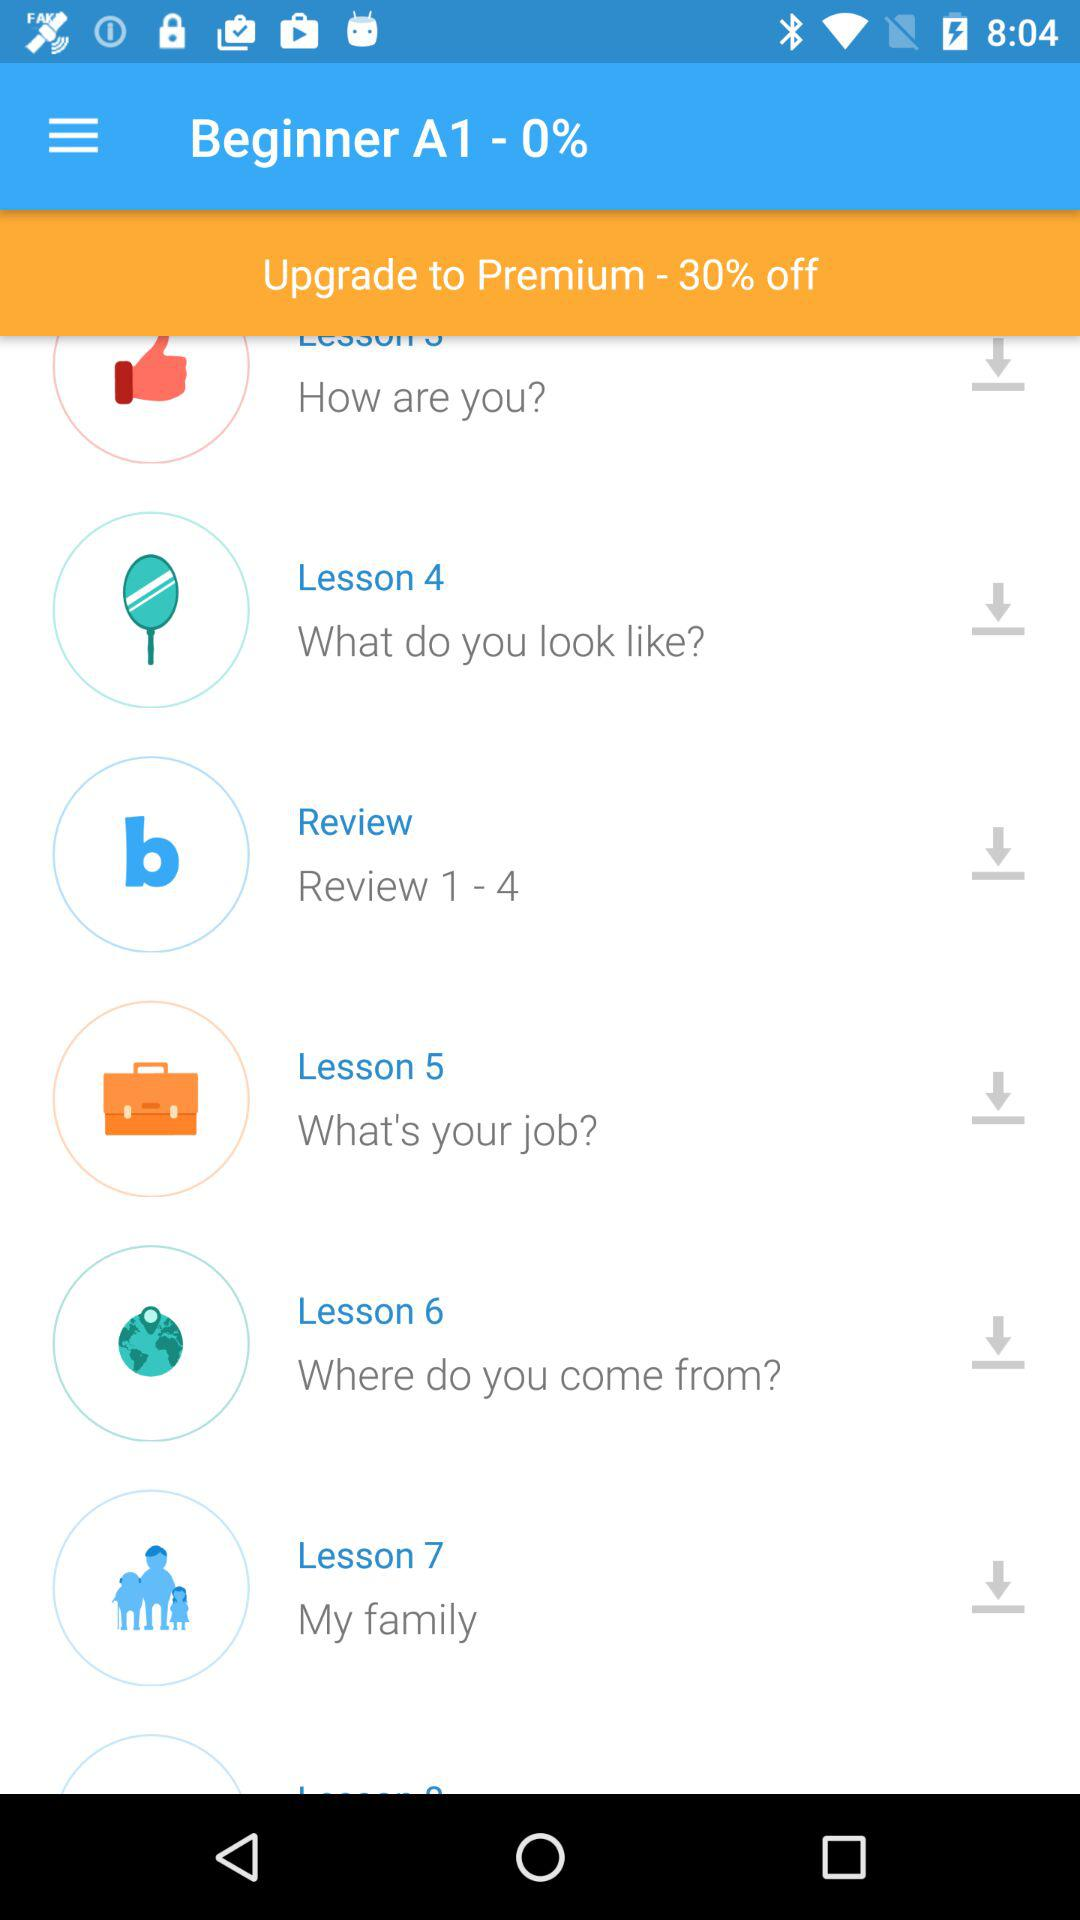What is the offer on upgrading to premium? The offer is 30%. 